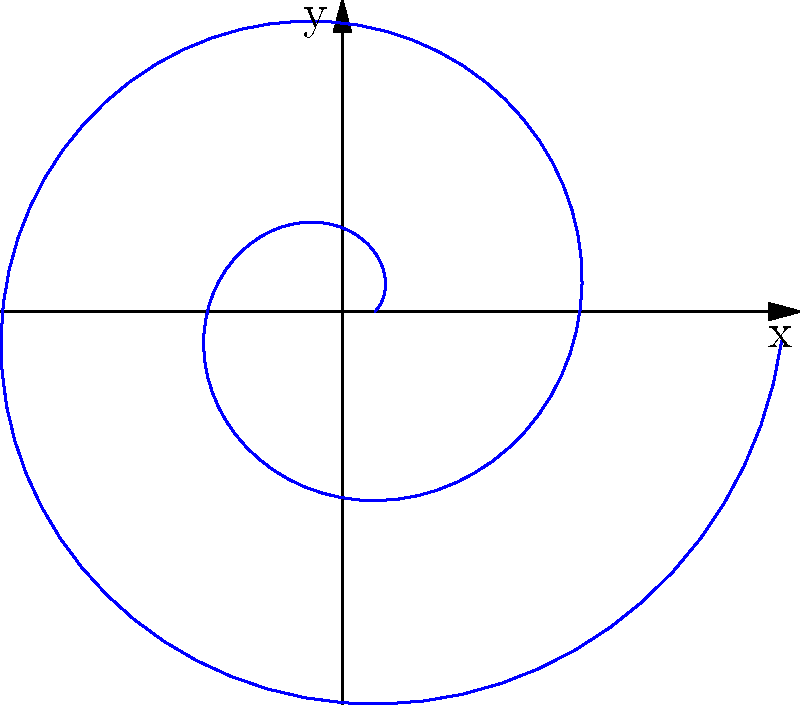In a beginner-friendly drawing application, students are asked to create a spiral pattern using polar coordinates. The spiral is defined by the equation $r = a + b\theta$, where $a = 0.1$ and $b = 0.1$. If the spiral makes two complete revolutions, what is the maximum radial distance reached by the spiral? To find the maximum radial distance of the spiral after two complete revolutions, we can follow these steps:

1. Recall the equation of the spiral: $r = a + b\theta$
   Where $a = 0.1$ and $b = 0.1$

2. Two complete revolutions means $\theta$ goes from 0 to $4\pi$ radians.

3. To find the maximum radial distance, we substitute the maximum value of $\theta$:
   $r_{max} = a + b(4\pi)$

4. Now, let's substitute the values:
   $r_{max} = 0.1 + 0.1(4\pi)$

5. Simplify:
   $r_{max} = 0.1 + 0.4\pi$

6. Calculate the final value:
   $r_{max} \approx 1.357$

Therefore, the maximum radial distance reached by the spiral after two complete revolutions is approximately 1.357 units.
Answer: $0.1 + 0.4\pi$ (or approximately 1.357 units) 